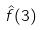<formula> <loc_0><loc_0><loc_500><loc_500>\hat { f } ( 3 )</formula> 